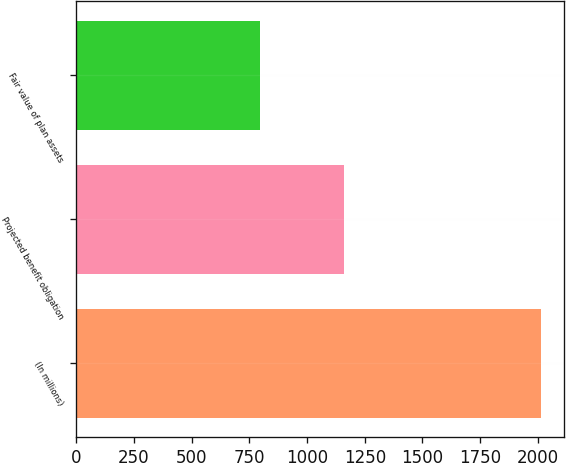<chart> <loc_0><loc_0><loc_500><loc_500><bar_chart><fcel>(In millions)<fcel>Projected benefit obligation<fcel>Fair value of plan assets<nl><fcel>2012<fcel>1162<fcel>795.7<nl></chart> 